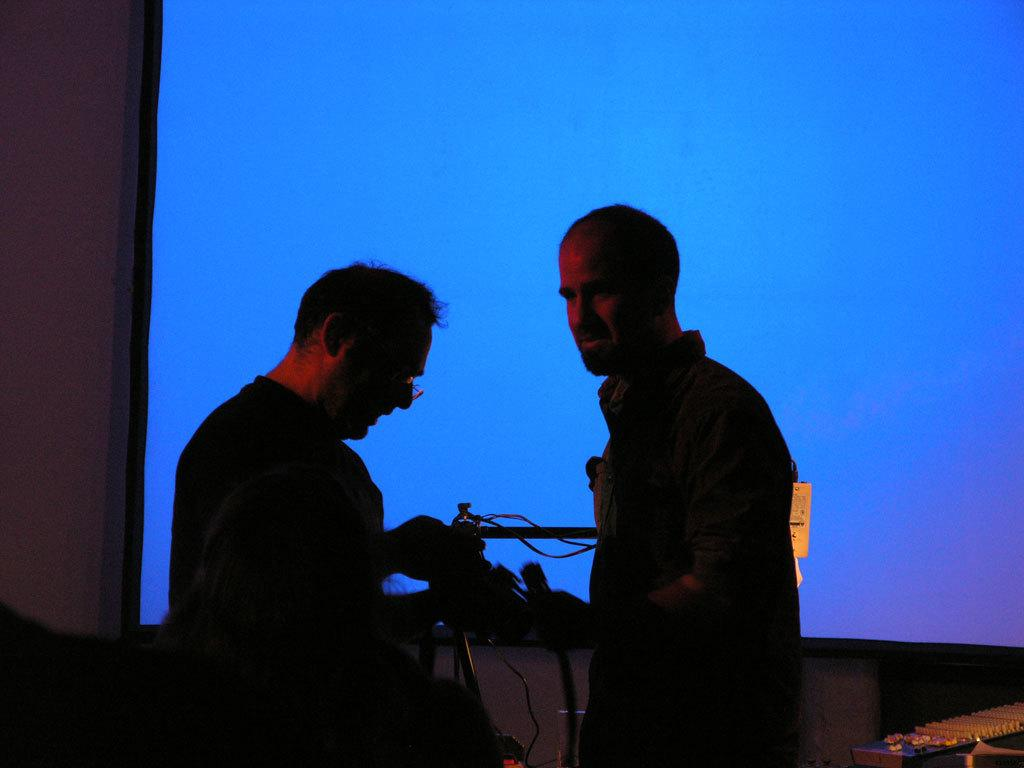How many people are in the image? There are three persons in the image. What are the persons doing in the image? The persons are standing. What are the persons holding in their hands? The persons are holding objects in their hands. What color is the screen visible in the background of the image? There is a blue color screen in the background of the image. Can you hear the bells ringing in the image? There are no bells present in the image, so it is not possible to hear them ringing. What type of payment method is being used in the image? There is no payment method depicted in the image; it only shows three persons standing and holding objects in their hands. 